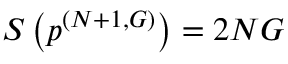Convert formula to latex. <formula><loc_0><loc_0><loc_500><loc_500>S \left ( p ^ { ( N + 1 , G ) } \right ) = 2 N G</formula> 